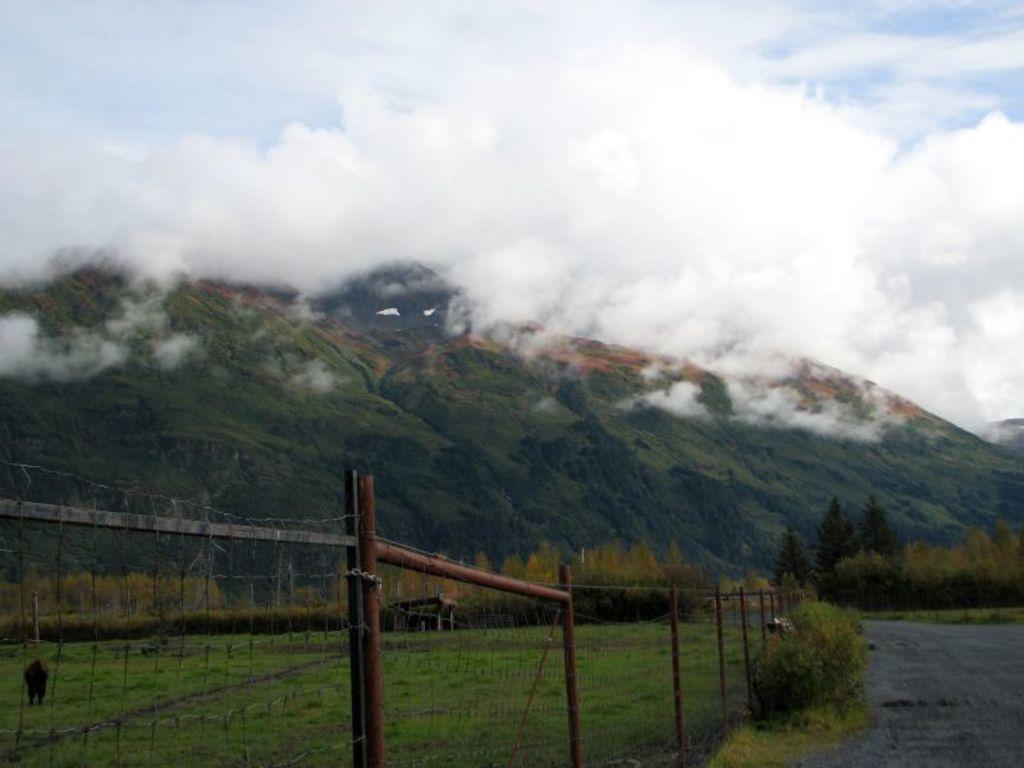Can you describe this image briefly? At the bottom of the picture, we see the fence. Beside that, we see planets and the grass. In the right bottom, we see the road. There are trees and hills in the background. At the top, we see the sky. On the left side, we see an animal in black color. In the middle of the picture, we see the shed. 